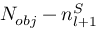<formula> <loc_0><loc_0><loc_500><loc_500>N _ { o b j } - n _ { l + 1 } ^ { S }</formula> 